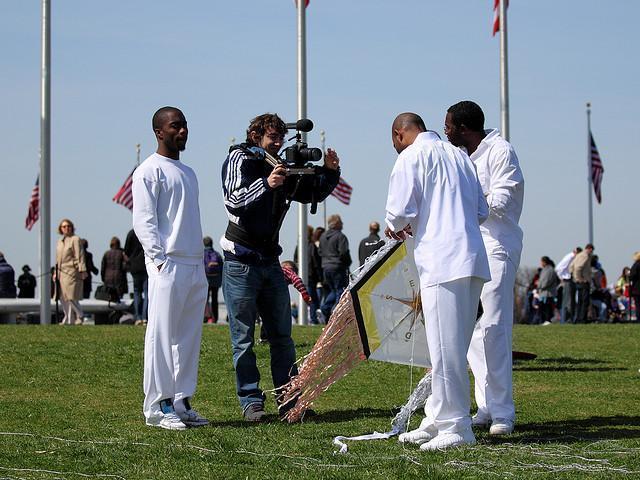What is the occupation of the man holding a camera?
Indicate the correct response and explain using: 'Answer: answer
Rationale: rationale.'
Options: Actor, athlete, film director, reporter. Answer: reporter.
Rationale: Most reporters move around with cameras. 